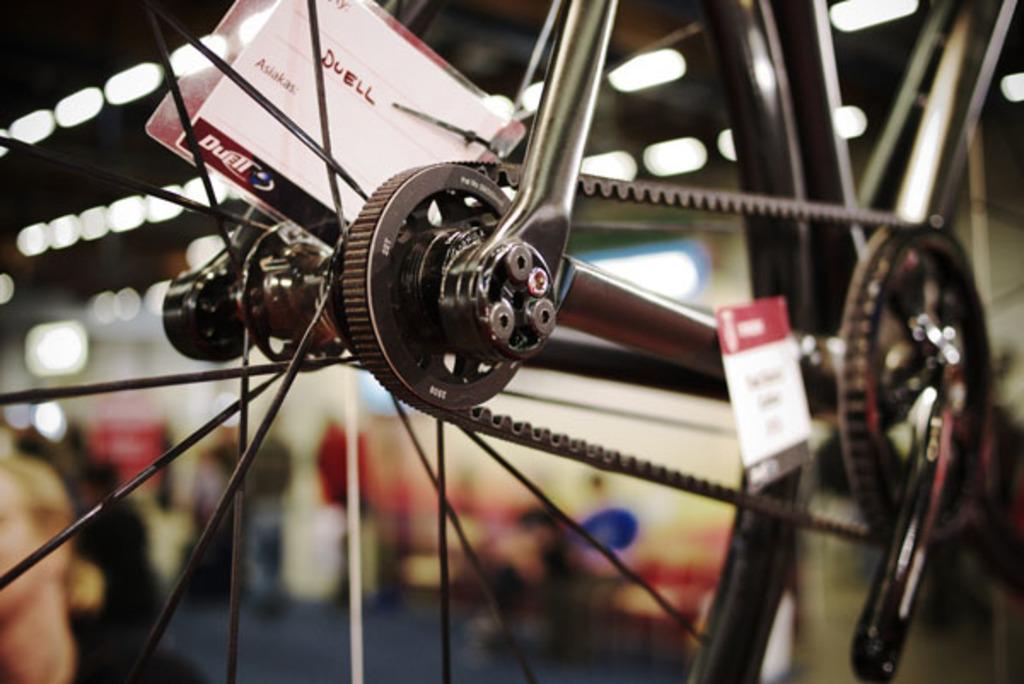In one or two sentences, can you explain what this image depicts? In this image there is a bicycle, there are cards, there is text on the cards, there are persons, there is a roof towards the top of the image, there are lights, the background of the image is blurred. 